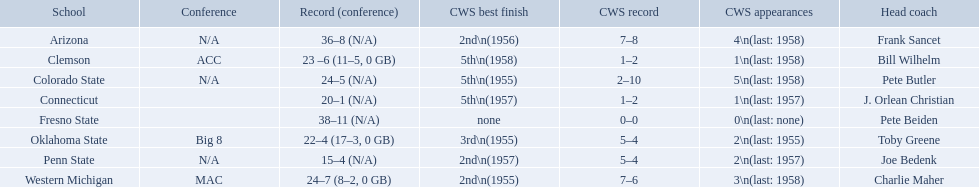What was the least amount of wins recorded by the losingest team? 15–4 (N/A). Which team held this record? Penn State. 